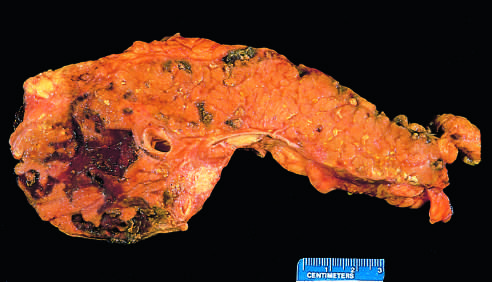have t_h17 cells been sectioned longitudinally to reveal dark areas of hemorrhage in the pancreatic substance and a focal area of pale fat necrosis in the peripancreatic fat upper left?
Answer the question using a single word or phrase. No 